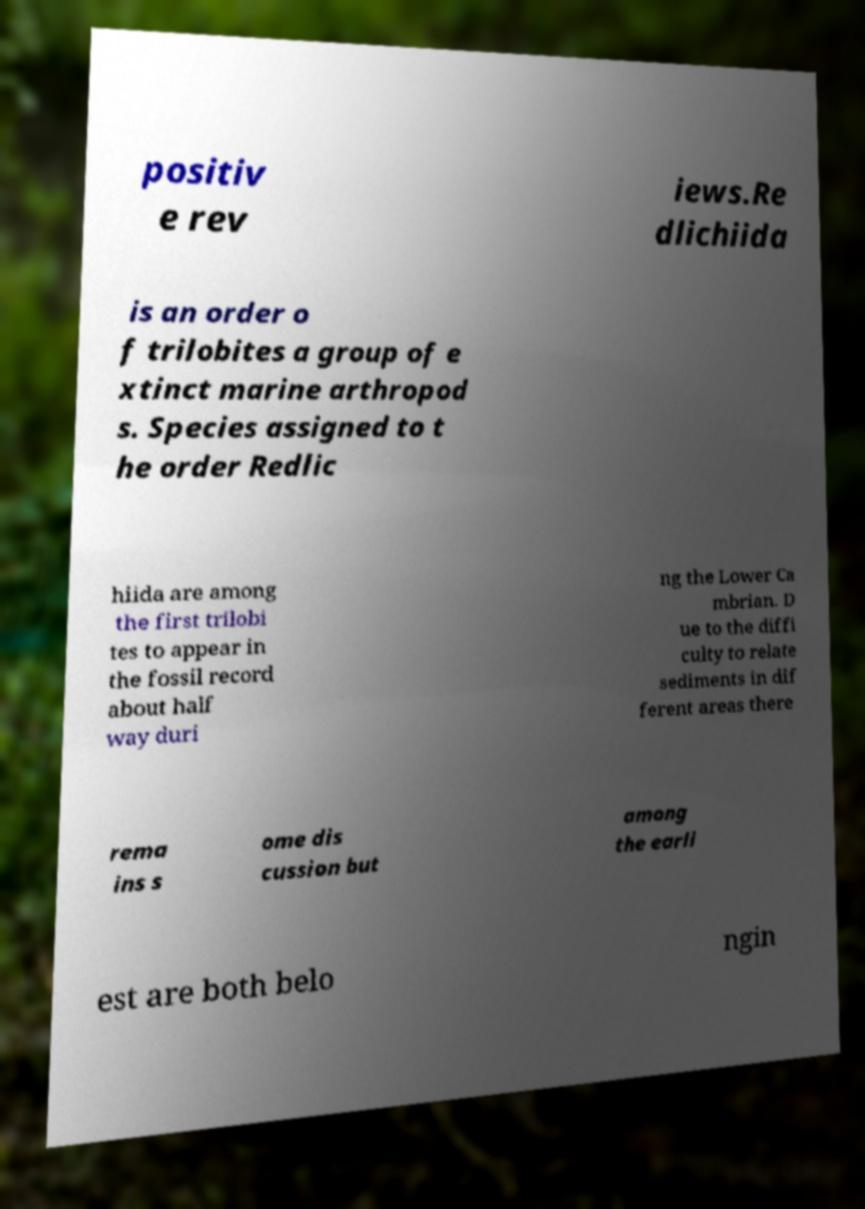Can you accurately transcribe the text from the provided image for me? positiv e rev iews.Re dlichiida is an order o f trilobites a group of e xtinct marine arthropod s. Species assigned to t he order Redlic hiida are among the first trilobi tes to appear in the fossil record about half way duri ng the Lower Ca mbrian. D ue to the diffi culty to relate sediments in dif ferent areas there rema ins s ome dis cussion but among the earli est are both belo ngin 